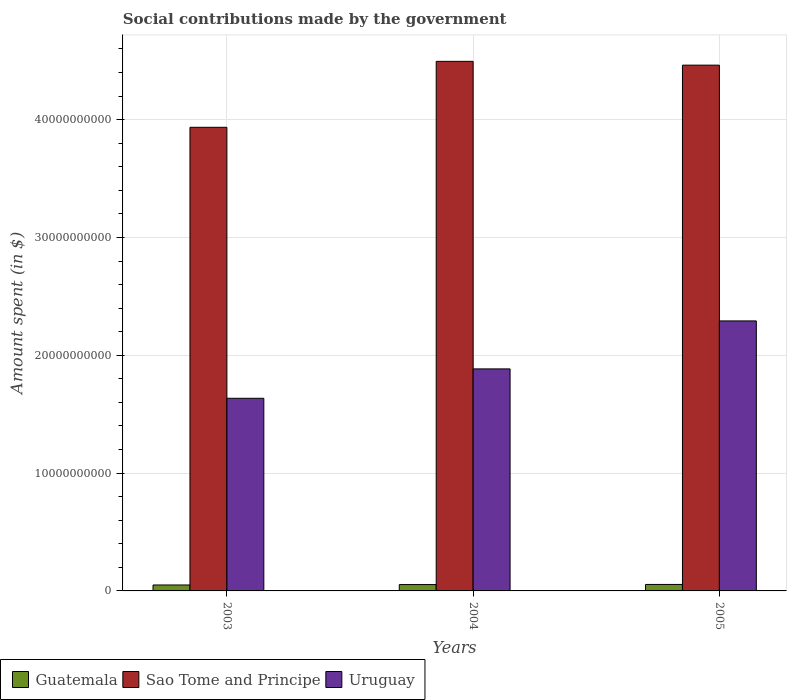How many groups of bars are there?
Give a very brief answer. 3. Are the number of bars on each tick of the X-axis equal?
Provide a short and direct response. Yes. How many bars are there on the 3rd tick from the right?
Your answer should be compact. 3. What is the amount spent on social contributions in Sao Tome and Principe in 2003?
Your answer should be very brief. 3.94e+1. Across all years, what is the maximum amount spent on social contributions in Uruguay?
Your answer should be compact. 2.29e+1. Across all years, what is the minimum amount spent on social contributions in Uruguay?
Offer a terse response. 1.64e+1. What is the total amount spent on social contributions in Uruguay in the graph?
Give a very brief answer. 5.81e+1. What is the difference between the amount spent on social contributions in Sao Tome and Principe in 2003 and that in 2005?
Make the answer very short. -5.28e+09. What is the difference between the amount spent on social contributions in Sao Tome and Principe in 2005 and the amount spent on social contributions in Guatemala in 2004?
Provide a succinct answer. 4.41e+1. What is the average amount spent on social contributions in Sao Tome and Principe per year?
Make the answer very short. 4.30e+1. In the year 2005, what is the difference between the amount spent on social contributions in Uruguay and amount spent on social contributions in Guatemala?
Offer a very short reply. 2.24e+1. What is the ratio of the amount spent on social contributions in Guatemala in 2003 to that in 2005?
Your response must be concise. 0.92. Is the amount spent on social contributions in Sao Tome and Principe in 2003 less than that in 2004?
Your answer should be compact. Yes. Is the difference between the amount spent on social contributions in Uruguay in 2003 and 2004 greater than the difference between the amount spent on social contributions in Guatemala in 2003 and 2004?
Provide a succinct answer. No. What is the difference between the highest and the second highest amount spent on social contributions in Sao Tome and Principe?
Your answer should be very brief. 3.23e+08. What is the difference between the highest and the lowest amount spent on social contributions in Guatemala?
Your answer should be very brief. 4.52e+07. What does the 3rd bar from the left in 2004 represents?
Your answer should be compact. Uruguay. What does the 2nd bar from the right in 2005 represents?
Offer a terse response. Sao Tome and Principe. How many bars are there?
Your answer should be very brief. 9. Are all the bars in the graph horizontal?
Keep it short and to the point. No. Are the values on the major ticks of Y-axis written in scientific E-notation?
Offer a terse response. No. Does the graph contain grids?
Offer a very short reply. Yes. How are the legend labels stacked?
Give a very brief answer. Horizontal. What is the title of the graph?
Make the answer very short. Social contributions made by the government. Does "Japan" appear as one of the legend labels in the graph?
Ensure brevity in your answer.  No. What is the label or title of the X-axis?
Provide a succinct answer. Years. What is the label or title of the Y-axis?
Provide a short and direct response. Amount spent (in $). What is the Amount spent (in $) of Guatemala in 2003?
Your answer should be compact. 5.05e+08. What is the Amount spent (in $) in Sao Tome and Principe in 2003?
Provide a short and direct response. 3.94e+1. What is the Amount spent (in $) of Uruguay in 2003?
Offer a terse response. 1.64e+1. What is the Amount spent (in $) of Guatemala in 2004?
Offer a terse response. 5.40e+08. What is the Amount spent (in $) in Sao Tome and Principe in 2004?
Your answer should be very brief. 4.50e+1. What is the Amount spent (in $) in Uruguay in 2004?
Keep it short and to the point. 1.88e+1. What is the Amount spent (in $) in Guatemala in 2005?
Ensure brevity in your answer.  5.50e+08. What is the Amount spent (in $) of Sao Tome and Principe in 2005?
Give a very brief answer. 4.46e+1. What is the Amount spent (in $) of Uruguay in 2005?
Ensure brevity in your answer.  2.29e+1. Across all years, what is the maximum Amount spent (in $) in Guatemala?
Keep it short and to the point. 5.50e+08. Across all years, what is the maximum Amount spent (in $) in Sao Tome and Principe?
Offer a very short reply. 4.50e+1. Across all years, what is the maximum Amount spent (in $) of Uruguay?
Offer a terse response. 2.29e+1. Across all years, what is the minimum Amount spent (in $) in Guatemala?
Keep it short and to the point. 5.05e+08. Across all years, what is the minimum Amount spent (in $) of Sao Tome and Principe?
Give a very brief answer. 3.94e+1. Across all years, what is the minimum Amount spent (in $) of Uruguay?
Keep it short and to the point. 1.64e+1. What is the total Amount spent (in $) of Guatemala in the graph?
Offer a very short reply. 1.59e+09. What is the total Amount spent (in $) of Sao Tome and Principe in the graph?
Your answer should be compact. 1.29e+11. What is the total Amount spent (in $) in Uruguay in the graph?
Your answer should be very brief. 5.81e+1. What is the difference between the Amount spent (in $) in Guatemala in 2003 and that in 2004?
Your answer should be very brief. -3.50e+07. What is the difference between the Amount spent (in $) in Sao Tome and Principe in 2003 and that in 2004?
Keep it short and to the point. -5.60e+09. What is the difference between the Amount spent (in $) in Uruguay in 2003 and that in 2004?
Make the answer very short. -2.50e+09. What is the difference between the Amount spent (in $) in Guatemala in 2003 and that in 2005?
Provide a short and direct response. -4.52e+07. What is the difference between the Amount spent (in $) in Sao Tome and Principe in 2003 and that in 2005?
Give a very brief answer. -5.28e+09. What is the difference between the Amount spent (in $) in Uruguay in 2003 and that in 2005?
Offer a very short reply. -6.57e+09. What is the difference between the Amount spent (in $) in Guatemala in 2004 and that in 2005?
Provide a short and direct response. -1.01e+07. What is the difference between the Amount spent (in $) in Sao Tome and Principe in 2004 and that in 2005?
Provide a succinct answer. 3.23e+08. What is the difference between the Amount spent (in $) of Uruguay in 2004 and that in 2005?
Your answer should be compact. -4.07e+09. What is the difference between the Amount spent (in $) in Guatemala in 2003 and the Amount spent (in $) in Sao Tome and Principe in 2004?
Your answer should be very brief. -4.44e+1. What is the difference between the Amount spent (in $) in Guatemala in 2003 and the Amount spent (in $) in Uruguay in 2004?
Offer a very short reply. -1.83e+1. What is the difference between the Amount spent (in $) in Sao Tome and Principe in 2003 and the Amount spent (in $) in Uruguay in 2004?
Your answer should be very brief. 2.05e+1. What is the difference between the Amount spent (in $) of Guatemala in 2003 and the Amount spent (in $) of Sao Tome and Principe in 2005?
Provide a short and direct response. -4.41e+1. What is the difference between the Amount spent (in $) in Guatemala in 2003 and the Amount spent (in $) in Uruguay in 2005?
Your answer should be very brief. -2.24e+1. What is the difference between the Amount spent (in $) of Sao Tome and Principe in 2003 and the Amount spent (in $) of Uruguay in 2005?
Keep it short and to the point. 1.64e+1. What is the difference between the Amount spent (in $) in Guatemala in 2004 and the Amount spent (in $) in Sao Tome and Principe in 2005?
Keep it short and to the point. -4.41e+1. What is the difference between the Amount spent (in $) in Guatemala in 2004 and the Amount spent (in $) in Uruguay in 2005?
Your answer should be compact. -2.24e+1. What is the difference between the Amount spent (in $) of Sao Tome and Principe in 2004 and the Amount spent (in $) of Uruguay in 2005?
Your response must be concise. 2.20e+1. What is the average Amount spent (in $) of Guatemala per year?
Keep it short and to the point. 5.31e+08. What is the average Amount spent (in $) of Sao Tome and Principe per year?
Keep it short and to the point. 4.30e+1. What is the average Amount spent (in $) in Uruguay per year?
Ensure brevity in your answer.  1.94e+1. In the year 2003, what is the difference between the Amount spent (in $) of Guatemala and Amount spent (in $) of Sao Tome and Principe?
Your answer should be very brief. -3.88e+1. In the year 2003, what is the difference between the Amount spent (in $) in Guatemala and Amount spent (in $) in Uruguay?
Keep it short and to the point. -1.58e+1. In the year 2003, what is the difference between the Amount spent (in $) in Sao Tome and Principe and Amount spent (in $) in Uruguay?
Keep it short and to the point. 2.30e+1. In the year 2004, what is the difference between the Amount spent (in $) in Guatemala and Amount spent (in $) in Sao Tome and Principe?
Your answer should be very brief. -4.44e+1. In the year 2004, what is the difference between the Amount spent (in $) in Guatemala and Amount spent (in $) in Uruguay?
Provide a short and direct response. -1.83e+1. In the year 2004, what is the difference between the Amount spent (in $) of Sao Tome and Principe and Amount spent (in $) of Uruguay?
Ensure brevity in your answer.  2.61e+1. In the year 2005, what is the difference between the Amount spent (in $) of Guatemala and Amount spent (in $) of Sao Tome and Principe?
Offer a terse response. -4.41e+1. In the year 2005, what is the difference between the Amount spent (in $) in Guatemala and Amount spent (in $) in Uruguay?
Make the answer very short. -2.24e+1. In the year 2005, what is the difference between the Amount spent (in $) in Sao Tome and Principe and Amount spent (in $) in Uruguay?
Provide a succinct answer. 2.17e+1. What is the ratio of the Amount spent (in $) of Guatemala in 2003 to that in 2004?
Offer a very short reply. 0.94. What is the ratio of the Amount spent (in $) in Sao Tome and Principe in 2003 to that in 2004?
Ensure brevity in your answer.  0.88. What is the ratio of the Amount spent (in $) of Uruguay in 2003 to that in 2004?
Offer a very short reply. 0.87. What is the ratio of the Amount spent (in $) in Guatemala in 2003 to that in 2005?
Your answer should be compact. 0.92. What is the ratio of the Amount spent (in $) in Sao Tome and Principe in 2003 to that in 2005?
Provide a succinct answer. 0.88. What is the ratio of the Amount spent (in $) in Uruguay in 2003 to that in 2005?
Make the answer very short. 0.71. What is the ratio of the Amount spent (in $) of Guatemala in 2004 to that in 2005?
Make the answer very short. 0.98. What is the ratio of the Amount spent (in $) of Sao Tome and Principe in 2004 to that in 2005?
Offer a very short reply. 1.01. What is the ratio of the Amount spent (in $) in Uruguay in 2004 to that in 2005?
Keep it short and to the point. 0.82. What is the difference between the highest and the second highest Amount spent (in $) in Guatemala?
Your answer should be compact. 1.01e+07. What is the difference between the highest and the second highest Amount spent (in $) of Sao Tome and Principe?
Your answer should be very brief. 3.23e+08. What is the difference between the highest and the second highest Amount spent (in $) of Uruguay?
Give a very brief answer. 4.07e+09. What is the difference between the highest and the lowest Amount spent (in $) in Guatemala?
Offer a terse response. 4.52e+07. What is the difference between the highest and the lowest Amount spent (in $) of Sao Tome and Principe?
Provide a short and direct response. 5.60e+09. What is the difference between the highest and the lowest Amount spent (in $) of Uruguay?
Your answer should be very brief. 6.57e+09. 